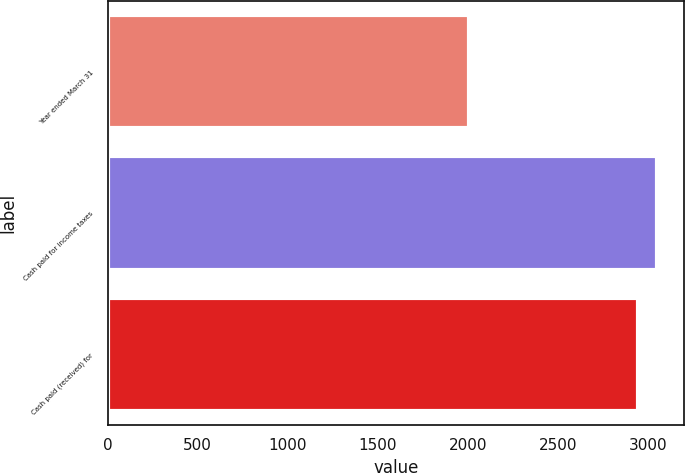<chart> <loc_0><loc_0><loc_500><loc_500><bar_chart><fcel>Year ended March 31<fcel>Cash paid for income taxes<fcel>Cash paid (received) for<nl><fcel>2002<fcel>3045.9<fcel>2942<nl></chart> 